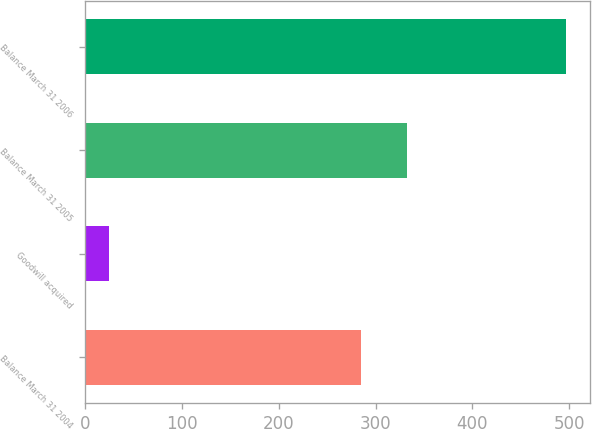<chart> <loc_0><loc_0><loc_500><loc_500><bar_chart><fcel>Balance March 31 2004<fcel>Goodwill acquired<fcel>Balance March 31 2005<fcel>Balance March 31 2006<nl><fcel>285<fcel>24<fcel>332.3<fcel>497<nl></chart> 